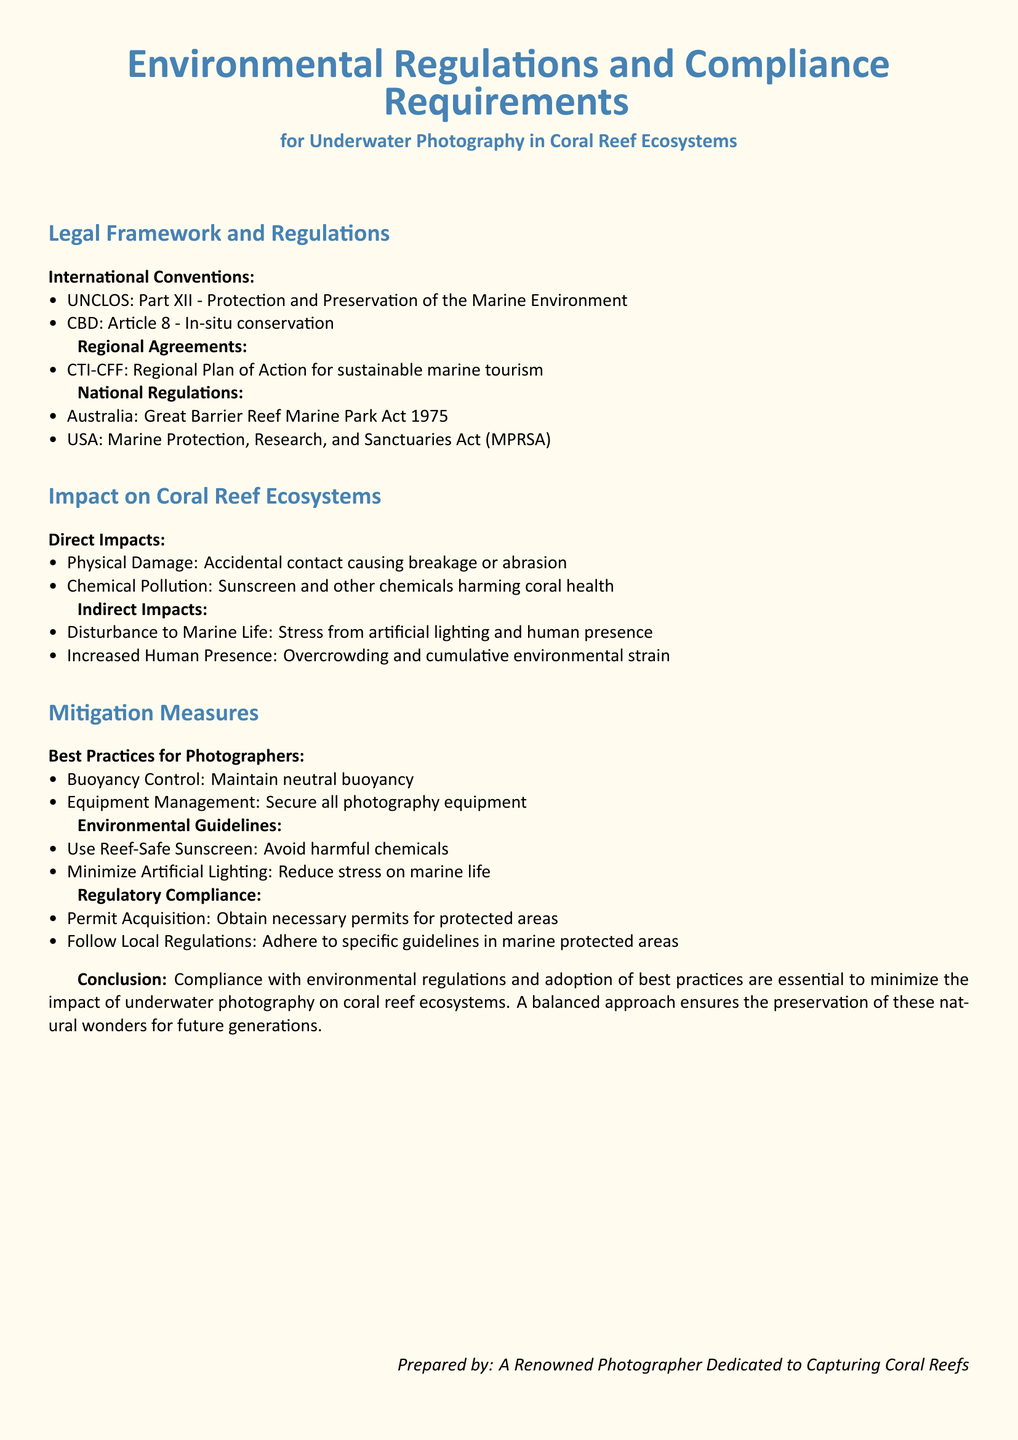What are the international conventions mentioned? The document lists UNCLOS and CBD as international conventions relevant to underwater photography regulations.
Answer: UNCLOS, CBD What does UNCLOS stand for? The abbreviation UNCLOS refers to the "United Nations Convention on the Law of the Sea."
Answer: United Nations Convention on the Law of the Sea What is highlighted as a direct impact on coral reefs? Physical Damage and Chemical Pollution are highlighted as direct impacts on coral reefs in the document.
Answer: Physical Damage, Chemical Pollution What practice should photographers maintain to mitigate impact on coral reefs? The document advises photographers to maintain neutral buoyancy as a best practice for underwater photography.
Answer: Neutral buoyancy What type of sunscreen should be used according to the guidelines? The guidelines state that photographers should use reef-safe sunscreen to minimize harm to coral reefs.
Answer: Reef-Safe Sunscreen Which act is associated with Australia regarding coral reef protection? The Great Barrier Reef Marine Park Act 1975 is mentioned as a relevant national regulation for Australia.
Answer: Great Barrier Reef Marine Park Act 1975 What should photographers secure to prevent environmental damage? Photographers are advised to secure all photography equipment to mitigate potential harm to coral reef ecosystems.
Answer: Photography equipment What is the conclusion of the document regarding environmental regulations? The document concludes that compliance and best practices are essential for minimizing impacts on coral reefs.
Answer: Essential for minimizing impacts 